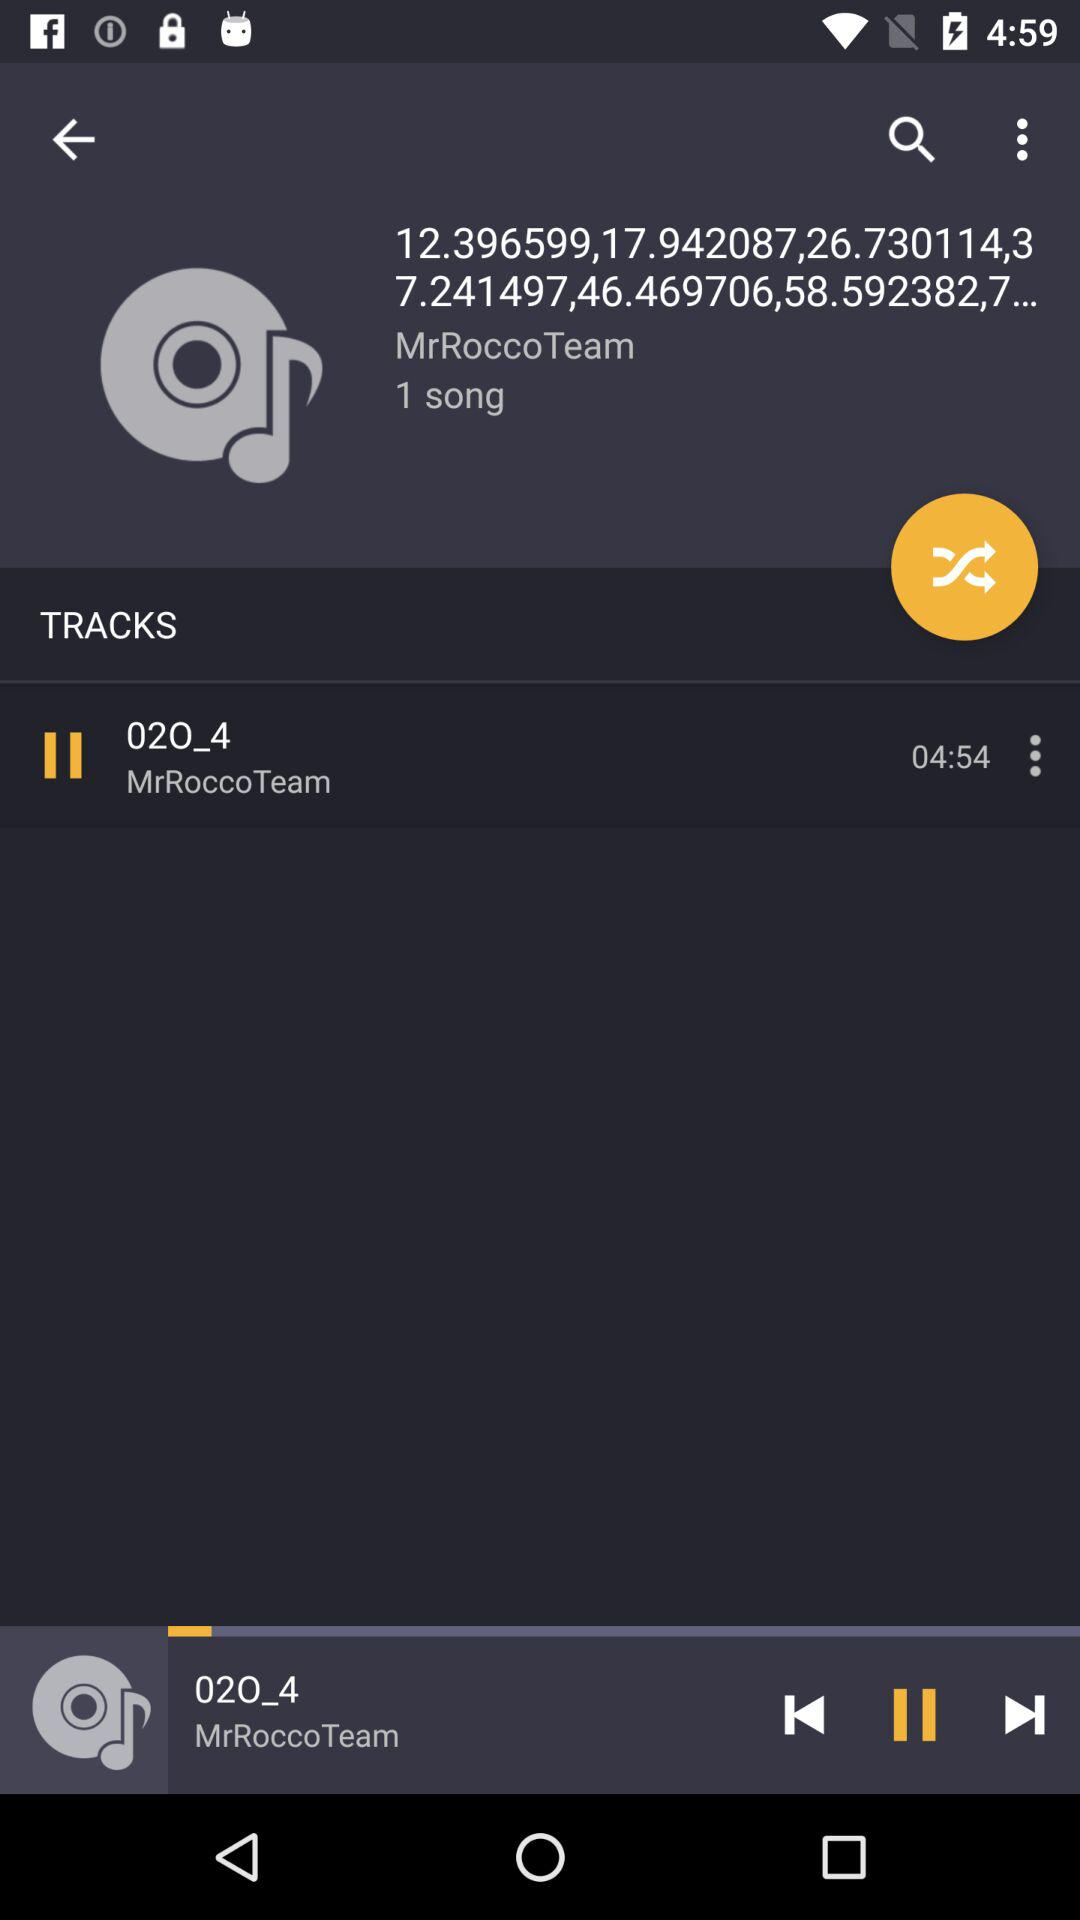What is the length of the song "02O_4"? The length of the song is 4 minutes 54 seconds. 